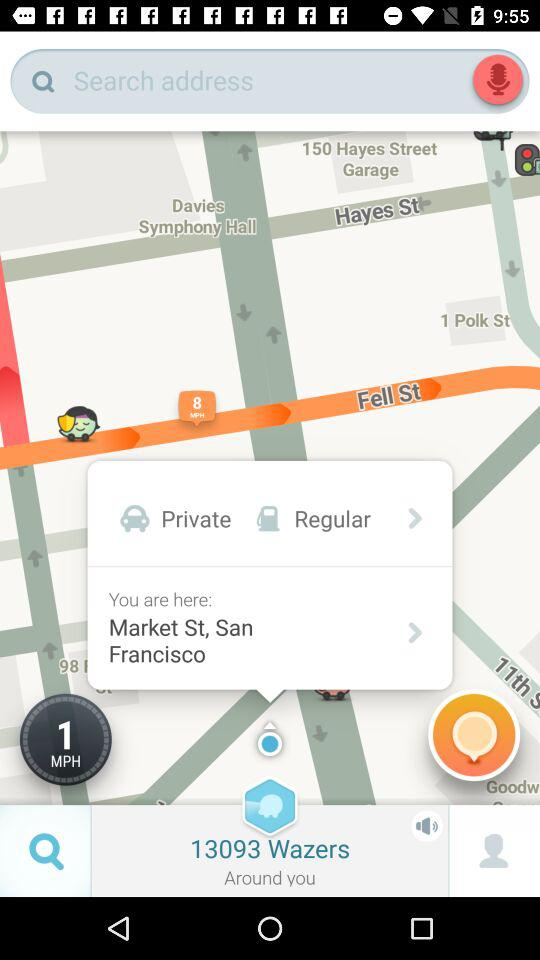What is the number of wazers? There are 13093 wazers. 